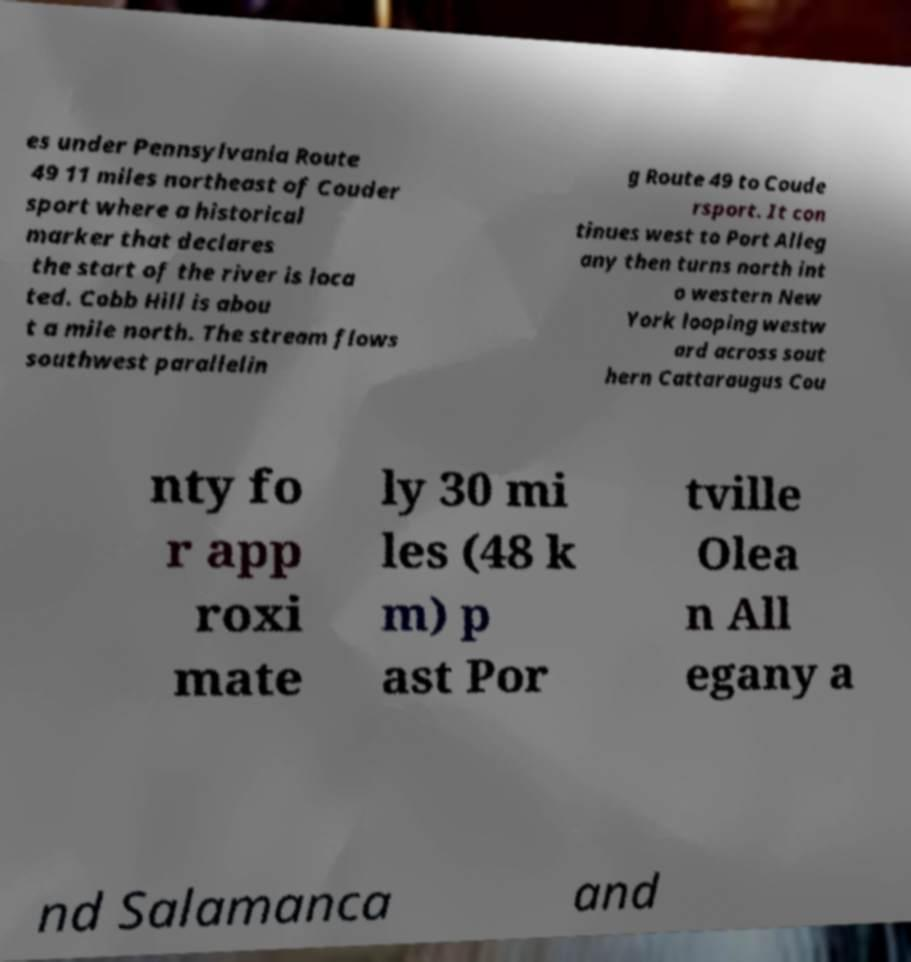For documentation purposes, I need the text within this image transcribed. Could you provide that? es under Pennsylvania Route 49 11 miles northeast of Couder sport where a historical marker that declares the start of the river is loca ted. Cobb Hill is abou t a mile north. The stream flows southwest parallelin g Route 49 to Coude rsport. It con tinues west to Port Alleg any then turns north int o western New York looping westw ard across sout hern Cattaraugus Cou nty fo r app roxi mate ly 30 mi les (48 k m) p ast Por tville Olea n All egany a nd Salamanca and 